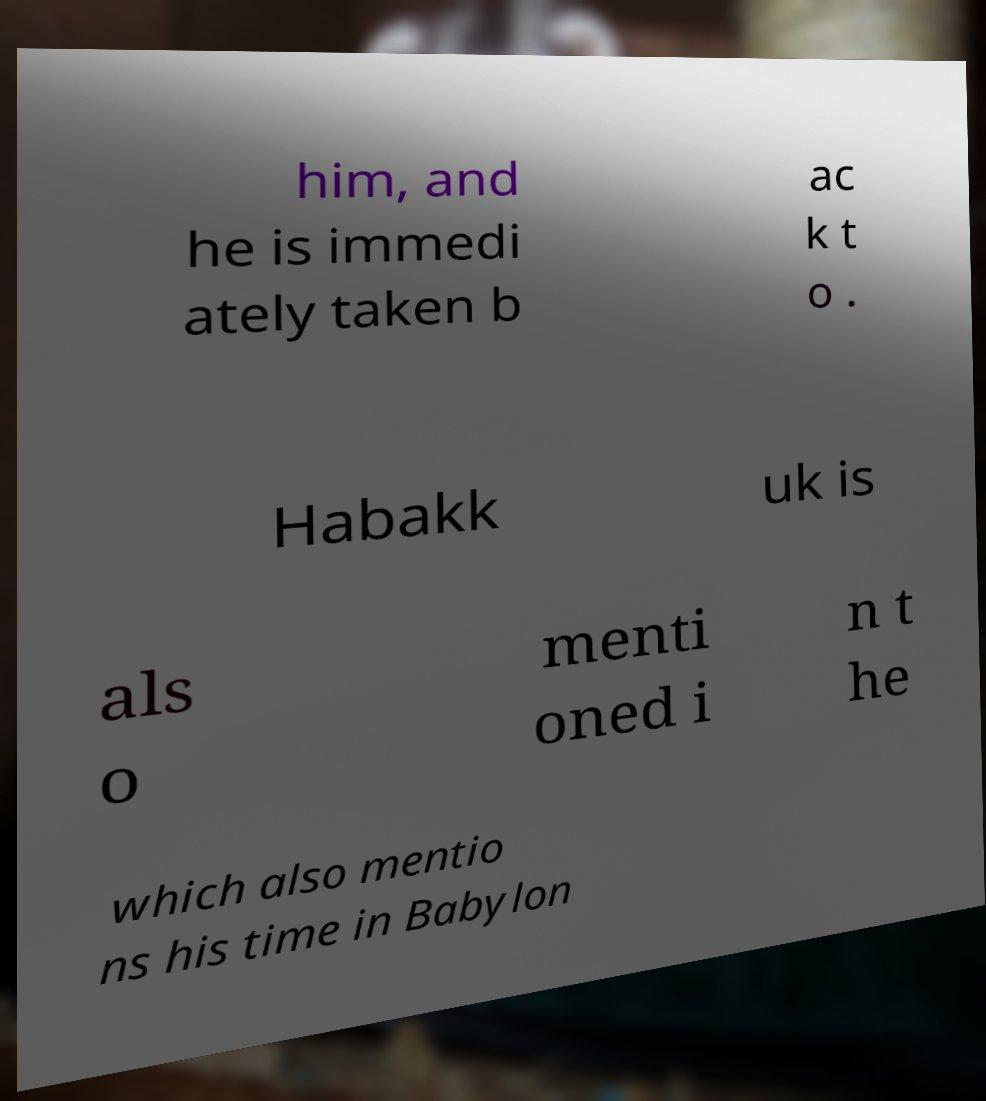I need the written content from this picture converted into text. Can you do that? him, and he is immedi ately taken b ac k t o . Habakk uk is als o menti oned i n t he which also mentio ns his time in Babylon 